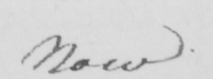What is written in this line of handwriting? Now 